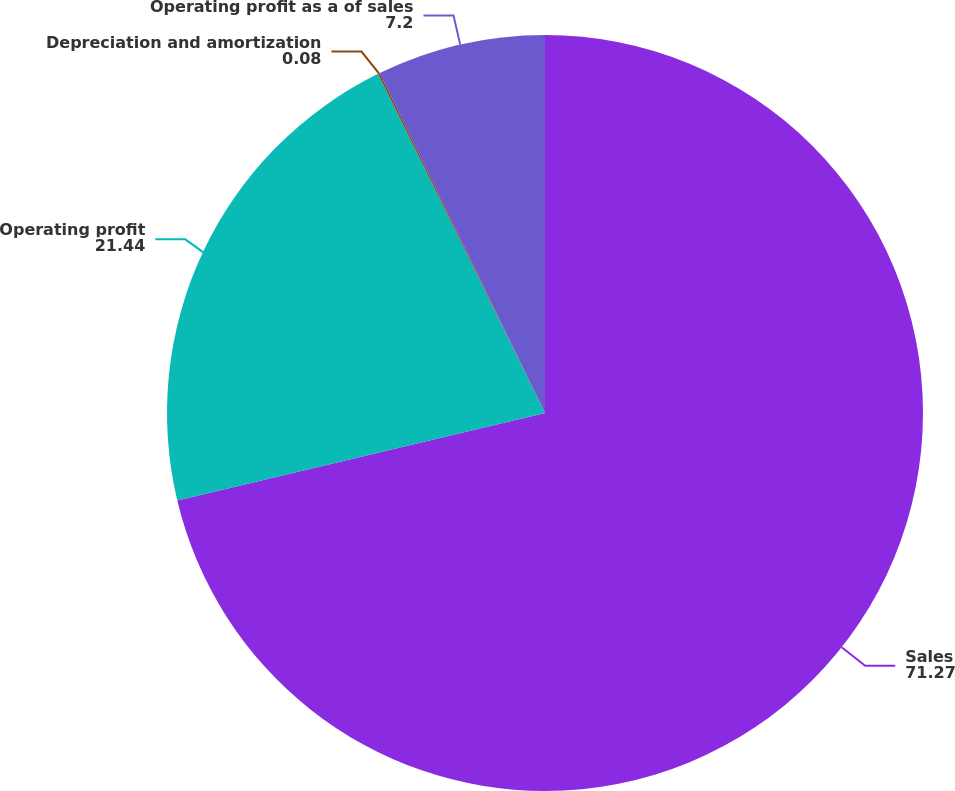Convert chart. <chart><loc_0><loc_0><loc_500><loc_500><pie_chart><fcel>Sales<fcel>Operating profit<fcel>Depreciation and amortization<fcel>Operating profit as a of sales<nl><fcel>71.27%<fcel>21.44%<fcel>0.08%<fcel>7.2%<nl></chart> 